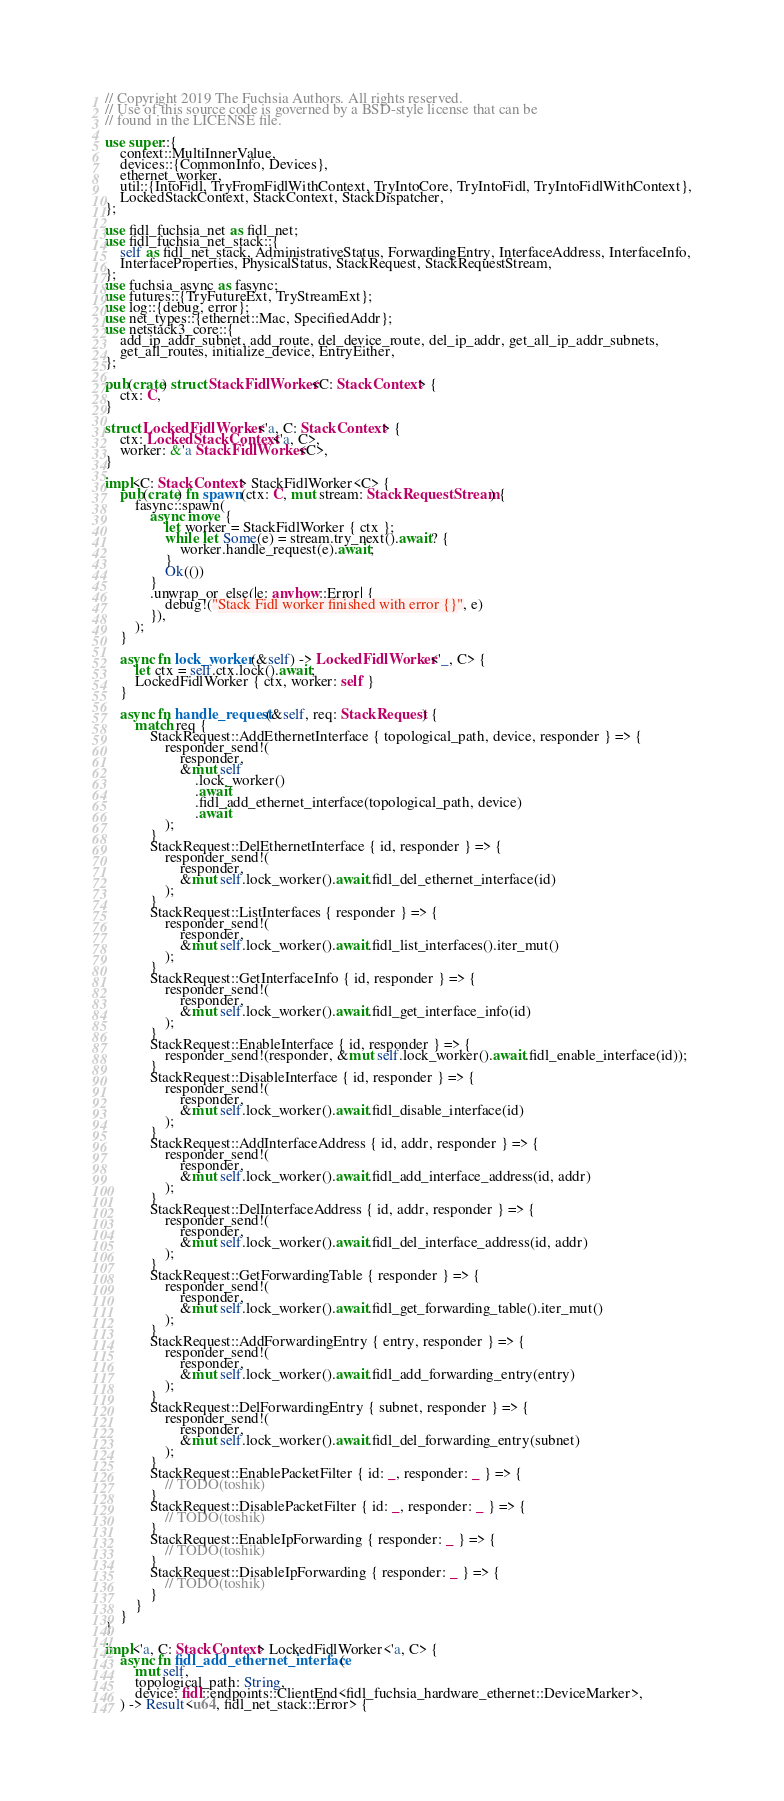Convert code to text. <code><loc_0><loc_0><loc_500><loc_500><_Rust_>// Copyright 2019 The Fuchsia Authors. All rights reserved.
// Use of this source code is governed by a BSD-style license that can be
// found in the LICENSE file.

use super::{
    context::MultiInnerValue,
    devices::{CommonInfo, Devices},
    ethernet_worker,
    util::{IntoFidl, TryFromFidlWithContext, TryIntoCore, TryIntoFidl, TryIntoFidlWithContext},
    LockedStackContext, StackContext, StackDispatcher,
};

use fidl_fuchsia_net as fidl_net;
use fidl_fuchsia_net_stack::{
    self as fidl_net_stack, AdministrativeStatus, ForwardingEntry, InterfaceAddress, InterfaceInfo,
    InterfaceProperties, PhysicalStatus, StackRequest, StackRequestStream,
};
use fuchsia_async as fasync;
use futures::{TryFutureExt, TryStreamExt};
use log::{debug, error};
use net_types::{ethernet::Mac, SpecifiedAddr};
use netstack3_core::{
    add_ip_addr_subnet, add_route, del_device_route, del_ip_addr, get_all_ip_addr_subnets,
    get_all_routes, initialize_device, EntryEither,
};

pub(crate) struct StackFidlWorker<C: StackContext> {
    ctx: C,
}

struct LockedFidlWorker<'a, C: StackContext> {
    ctx: LockedStackContext<'a, C>,
    worker: &'a StackFidlWorker<C>,
}

impl<C: StackContext> StackFidlWorker<C> {
    pub(crate) fn spawn(ctx: C, mut stream: StackRequestStream) {
        fasync::spawn(
            async move {
                let worker = StackFidlWorker { ctx };
                while let Some(e) = stream.try_next().await? {
                    worker.handle_request(e).await;
                }
                Ok(())
            }
            .unwrap_or_else(|e: anyhow::Error| {
                debug!("Stack Fidl worker finished with error {}", e)
            }),
        );
    }

    async fn lock_worker(&self) -> LockedFidlWorker<'_, C> {
        let ctx = self.ctx.lock().await;
        LockedFidlWorker { ctx, worker: self }
    }

    async fn handle_request(&self, req: StackRequest) {
        match req {
            StackRequest::AddEthernetInterface { topological_path, device, responder } => {
                responder_send!(
                    responder,
                    &mut self
                        .lock_worker()
                        .await
                        .fidl_add_ethernet_interface(topological_path, device)
                        .await
                );
            }
            StackRequest::DelEthernetInterface { id, responder } => {
                responder_send!(
                    responder,
                    &mut self.lock_worker().await.fidl_del_ethernet_interface(id)
                );
            }
            StackRequest::ListInterfaces { responder } => {
                responder_send!(
                    responder,
                    &mut self.lock_worker().await.fidl_list_interfaces().iter_mut()
                );
            }
            StackRequest::GetInterfaceInfo { id, responder } => {
                responder_send!(
                    responder,
                    &mut self.lock_worker().await.fidl_get_interface_info(id)
                );
            }
            StackRequest::EnableInterface { id, responder } => {
                responder_send!(responder, &mut self.lock_worker().await.fidl_enable_interface(id));
            }
            StackRequest::DisableInterface { id, responder } => {
                responder_send!(
                    responder,
                    &mut self.lock_worker().await.fidl_disable_interface(id)
                );
            }
            StackRequest::AddInterfaceAddress { id, addr, responder } => {
                responder_send!(
                    responder,
                    &mut self.lock_worker().await.fidl_add_interface_address(id, addr)
                );
            }
            StackRequest::DelInterfaceAddress { id, addr, responder } => {
                responder_send!(
                    responder,
                    &mut self.lock_worker().await.fidl_del_interface_address(id, addr)
                );
            }
            StackRequest::GetForwardingTable { responder } => {
                responder_send!(
                    responder,
                    &mut self.lock_worker().await.fidl_get_forwarding_table().iter_mut()
                );
            }
            StackRequest::AddForwardingEntry { entry, responder } => {
                responder_send!(
                    responder,
                    &mut self.lock_worker().await.fidl_add_forwarding_entry(entry)
                );
            }
            StackRequest::DelForwardingEntry { subnet, responder } => {
                responder_send!(
                    responder,
                    &mut self.lock_worker().await.fidl_del_forwarding_entry(subnet)
                );
            }
            StackRequest::EnablePacketFilter { id: _, responder: _ } => {
                // TODO(toshik)
            }
            StackRequest::DisablePacketFilter { id: _, responder: _ } => {
                // TODO(toshik)
            }
            StackRequest::EnableIpForwarding { responder: _ } => {
                // TODO(toshik)
            }
            StackRequest::DisableIpForwarding { responder: _ } => {
                // TODO(toshik)
            }
        }
    }
}

impl<'a, C: StackContext> LockedFidlWorker<'a, C> {
    async fn fidl_add_ethernet_interface(
        mut self,
        topological_path: String,
        device: fidl::endpoints::ClientEnd<fidl_fuchsia_hardware_ethernet::DeviceMarker>,
    ) -> Result<u64, fidl_net_stack::Error> {</code> 